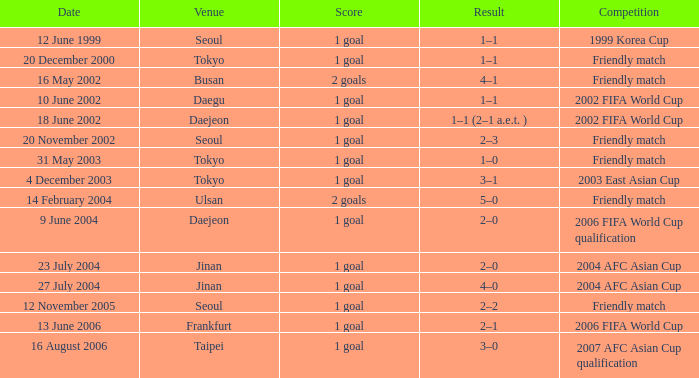What is the location for the event on 12 november 2005? Seoul. 